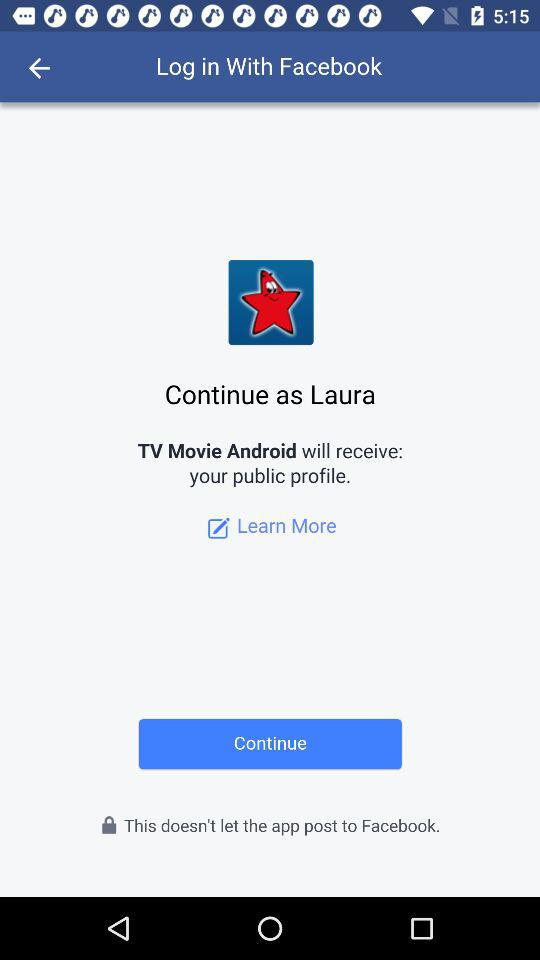What is the user name? The user name is Laura. 